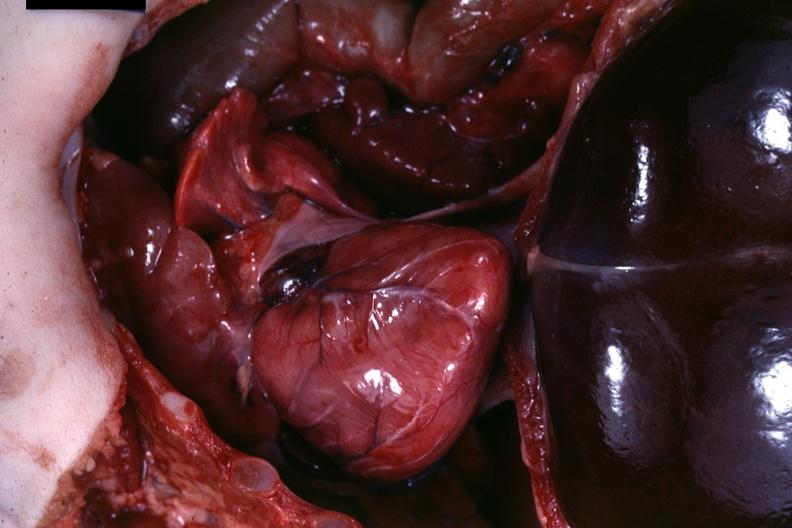s muscle present?
Answer the question using a single word or phrase. Yes 